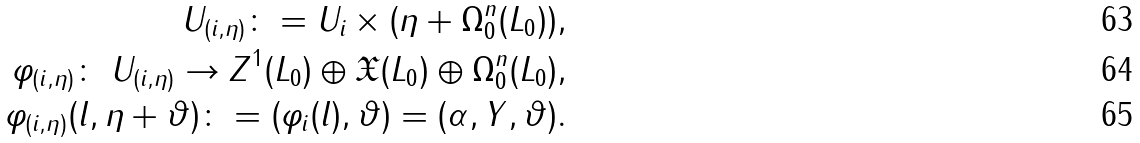<formula> <loc_0><loc_0><loc_500><loc_500>U _ { ( i , \eta ) } \colon = U _ { i } \times ( \eta + \Omega _ { 0 } ^ { n } ( L _ { 0 } ) ) , \\ \varphi _ { ( i , \eta ) } \colon \ U _ { ( i , \eta ) } \to Z ^ { 1 } ( L _ { 0 } ) \oplus \mathfrak { X } ( L _ { 0 } ) \oplus \Omega _ { 0 } ^ { n } ( L _ { 0 } ) , \\ \varphi _ { ( i , \eta ) } ( l , \eta + \vartheta ) \colon = ( \varphi _ { i } ( l ) , \vartheta ) = ( \alpha , Y , \vartheta ) .</formula> 